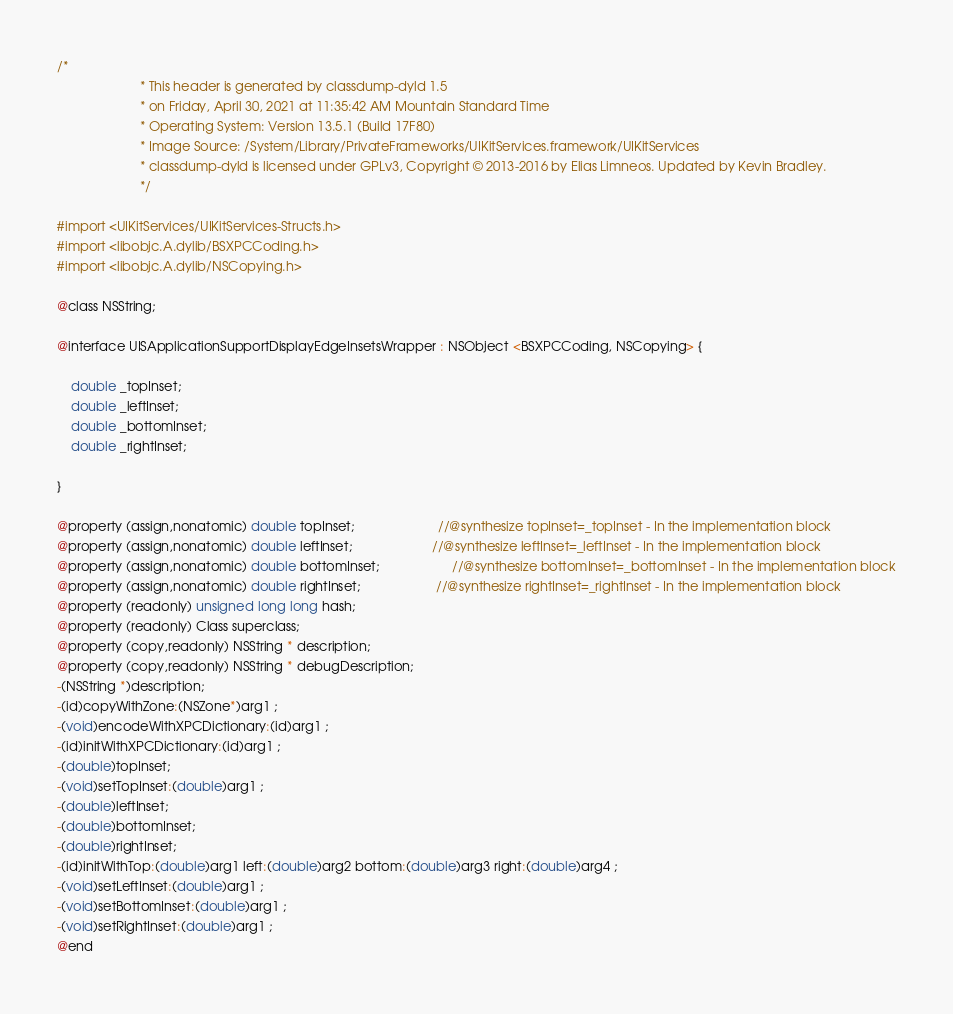Convert code to text. <code><loc_0><loc_0><loc_500><loc_500><_C_>/*
                       * This header is generated by classdump-dyld 1.5
                       * on Friday, April 30, 2021 at 11:35:42 AM Mountain Standard Time
                       * Operating System: Version 13.5.1 (Build 17F80)
                       * Image Source: /System/Library/PrivateFrameworks/UIKitServices.framework/UIKitServices
                       * classdump-dyld is licensed under GPLv3, Copyright © 2013-2016 by Elias Limneos. Updated by Kevin Bradley.
                       */

#import <UIKitServices/UIKitServices-Structs.h>
#import <libobjc.A.dylib/BSXPCCoding.h>
#import <libobjc.A.dylib/NSCopying.h>

@class NSString;

@interface UISApplicationSupportDisplayEdgeInsetsWrapper : NSObject <BSXPCCoding, NSCopying> {

	double _topInset;
	double _leftInset;
	double _bottomInset;
	double _rightInset;

}

@property (assign,nonatomic) double topInset;                       //@synthesize topInset=_topInset - In the implementation block
@property (assign,nonatomic) double leftInset;                      //@synthesize leftInset=_leftInset - In the implementation block
@property (assign,nonatomic) double bottomInset;                    //@synthesize bottomInset=_bottomInset - In the implementation block
@property (assign,nonatomic) double rightInset;                     //@synthesize rightInset=_rightInset - In the implementation block
@property (readonly) unsigned long long hash; 
@property (readonly) Class superclass; 
@property (copy,readonly) NSString * description; 
@property (copy,readonly) NSString * debugDescription; 
-(NSString *)description;
-(id)copyWithZone:(NSZone*)arg1 ;
-(void)encodeWithXPCDictionary:(id)arg1 ;
-(id)initWithXPCDictionary:(id)arg1 ;
-(double)topInset;
-(void)setTopInset:(double)arg1 ;
-(double)leftInset;
-(double)bottomInset;
-(double)rightInset;
-(id)initWithTop:(double)arg1 left:(double)arg2 bottom:(double)arg3 right:(double)arg4 ;
-(void)setLeftInset:(double)arg1 ;
-(void)setBottomInset:(double)arg1 ;
-(void)setRightInset:(double)arg1 ;
@end

</code> 